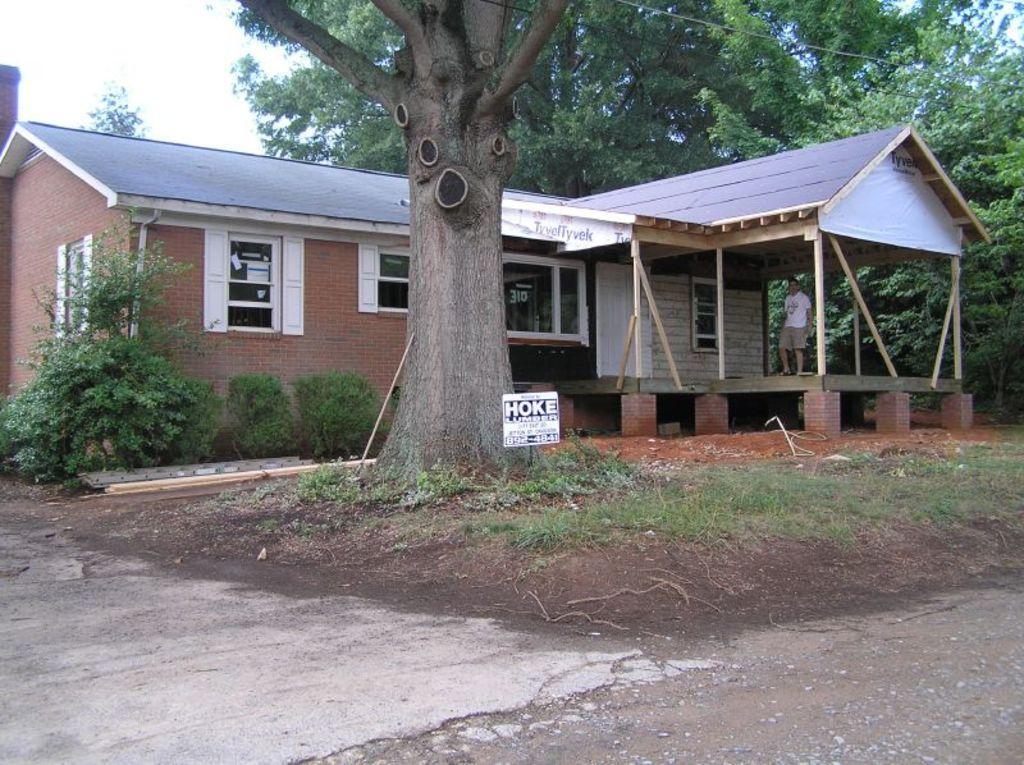Can you describe this image briefly? In this image I can see a house,windows,trees,wires,white color board and something is written on it. One person is standing and the sky is in white color. 